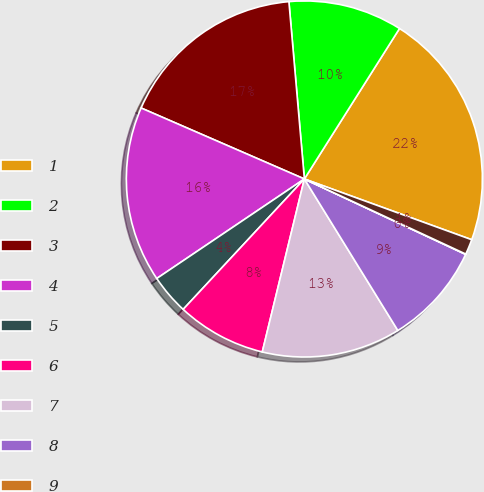Convert chart to OTSL. <chart><loc_0><loc_0><loc_500><loc_500><pie_chart><fcel>1<fcel>2<fcel>3<fcel>4<fcel>5<fcel>6<fcel>7<fcel>8<fcel>9<fcel>10<nl><fcel>21.57%<fcel>10.36%<fcel>17.09%<fcel>15.97%<fcel>3.64%<fcel>8.12%<fcel>12.6%<fcel>9.24%<fcel>0.03%<fcel>1.39%<nl></chart> 